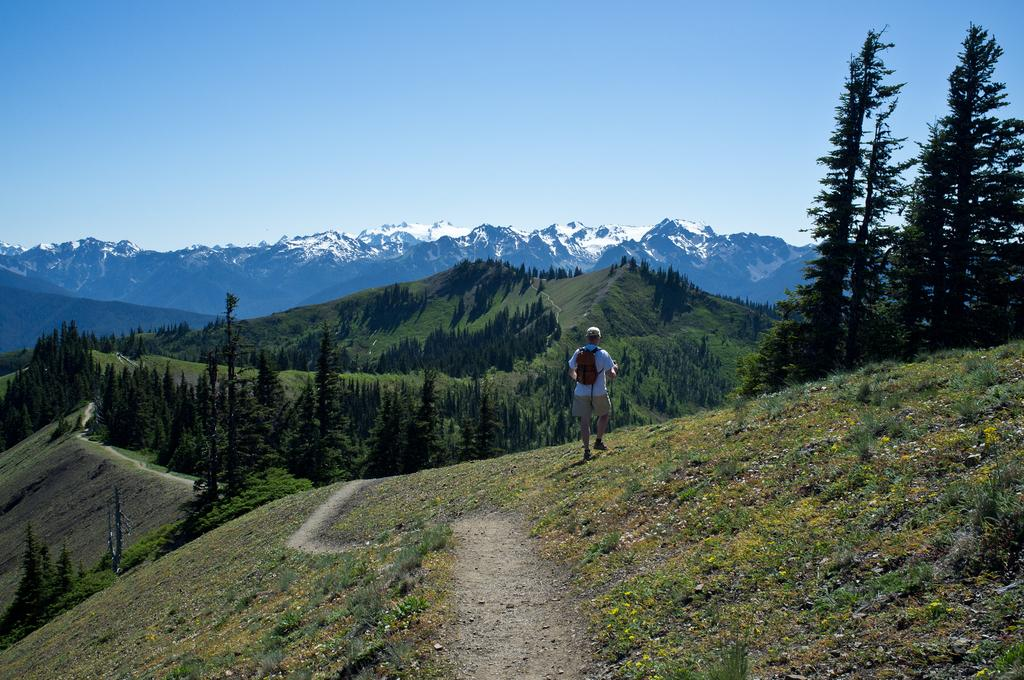What type of natural landscape is depicted in the image? The image features mountains and trees. Can you describe the person in the image? There is a person wearing a bag and walking in the image. What is the color of the sky in the image? The sky is blue and white in color. What type of mice can be seen running around in the image? There are no mice present in the image; it features mountains, trees, and a person walking. How does the taste of the trees in the image compare to the taste of the mountains? Trees and mountains are natural landscapes and do not have a taste. 